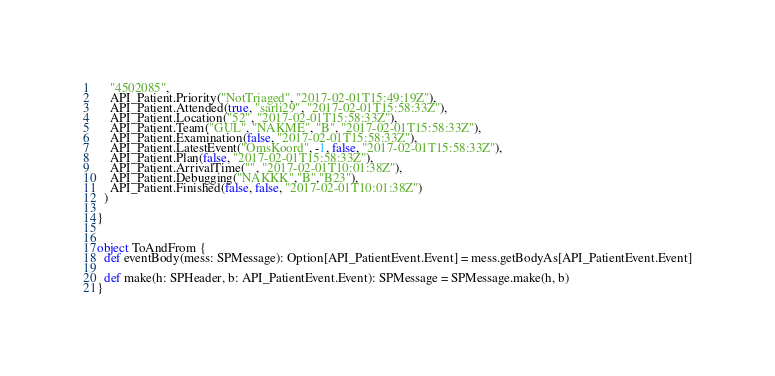Convert code to text. <code><loc_0><loc_0><loc_500><loc_500><_Scala_>    "4502085",
    API_Patient.Priority("NotTriaged", "2017-02-01T15:49:19Z"),
    API_Patient.Attended(true, "sarli29", "2017-02-01T15:58:33Z"),
    API_Patient.Location("52", "2017-02-01T15:58:33Z"),
    API_Patient.Team("GUL", "NAKME", "B", "2017-02-01T15:58:33Z"),
    API_Patient.Examination(false, "2017-02-01T15:58:33Z"),
    API_Patient.LatestEvent("OmsKoord", -1, false, "2017-02-01T15:58:33Z"),
    API_Patient.Plan(false, "2017-02-01T15:58:33Z"),
    API_Patient.ArrivalTime("", "2017-02-01T10:01:38Z"),
    API_Patient.Debugging("NAKKK","B","B23"),
    API_Patient.Finished(false, false, "2017-02-01T10:01:38Z")
  )

}


object ToAndFrom {
  def eventBody(mess: SPMessage): Option[API_PatientEvent.Event] = mess.getBodyAs[API_PatientEvent.Event]

  def make(h: SPHeader, b: API_PatientEvent.Event): SPMessage = SPMessage.make(h, b)
}
</code> 